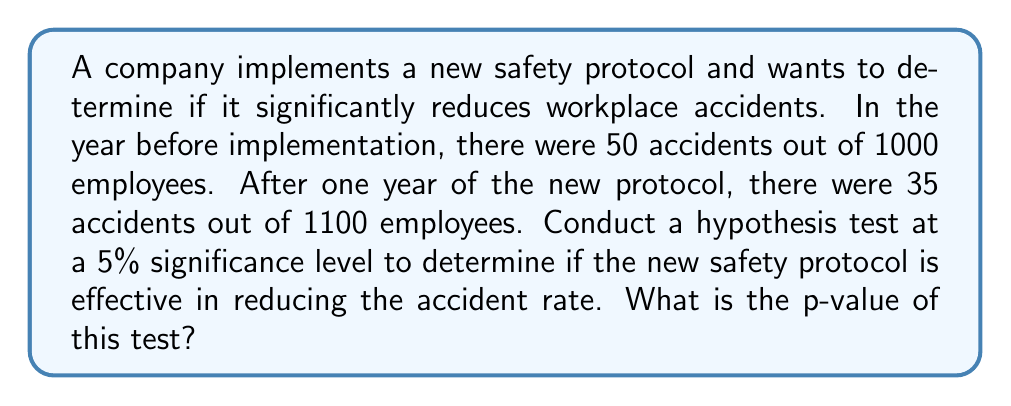Teach me how to tackle this problem. 1. Define the hypotheses:
   $H_0: p_1 = p_2$ (null hypothesis: accident rates are equal)
   $H_a: p_1 > p_2$ (alternative hypothesis: old rate is higher than new rate)

2. Calculate the pooled proportion:
   $$p = \frac{x_1 + x_2}{n_1 + n_2} = \frac{50 + 35}{1000 + 1100} = \frac{85}{2100} \approx 0.0405$$

3. Calculate the test statistic:
   $$z = \frac{(p_1 - p_2) - 0}{\sqrt{p(1-p)(\frac{1}{n_1} + \frac{1}{n_2})}}$$
   
   Where:
   $p_1 = 50/1000 = 0.05$
   $p_2 = 35/1100 \approx 0.0318$

   $$z = \frac{(0.05 - 0.0318) - 0}{\sqrt{0.0405(1-0.0405)(\frac{1}{1000} + \frac{1}{1100})}} \approx 2.3416$$

4. Find the p-value:
   For a one-tailed test, p-value = P(Z > z)
   Using a standard normal distribution table or calculator:
   p-value = 1 - Φ(2.3416) ≈ 0.0096

5. Compare p-value to significance level:
   0.0096 < 0.05, so we reject the null hypothesis.
Answer: 0.0096 